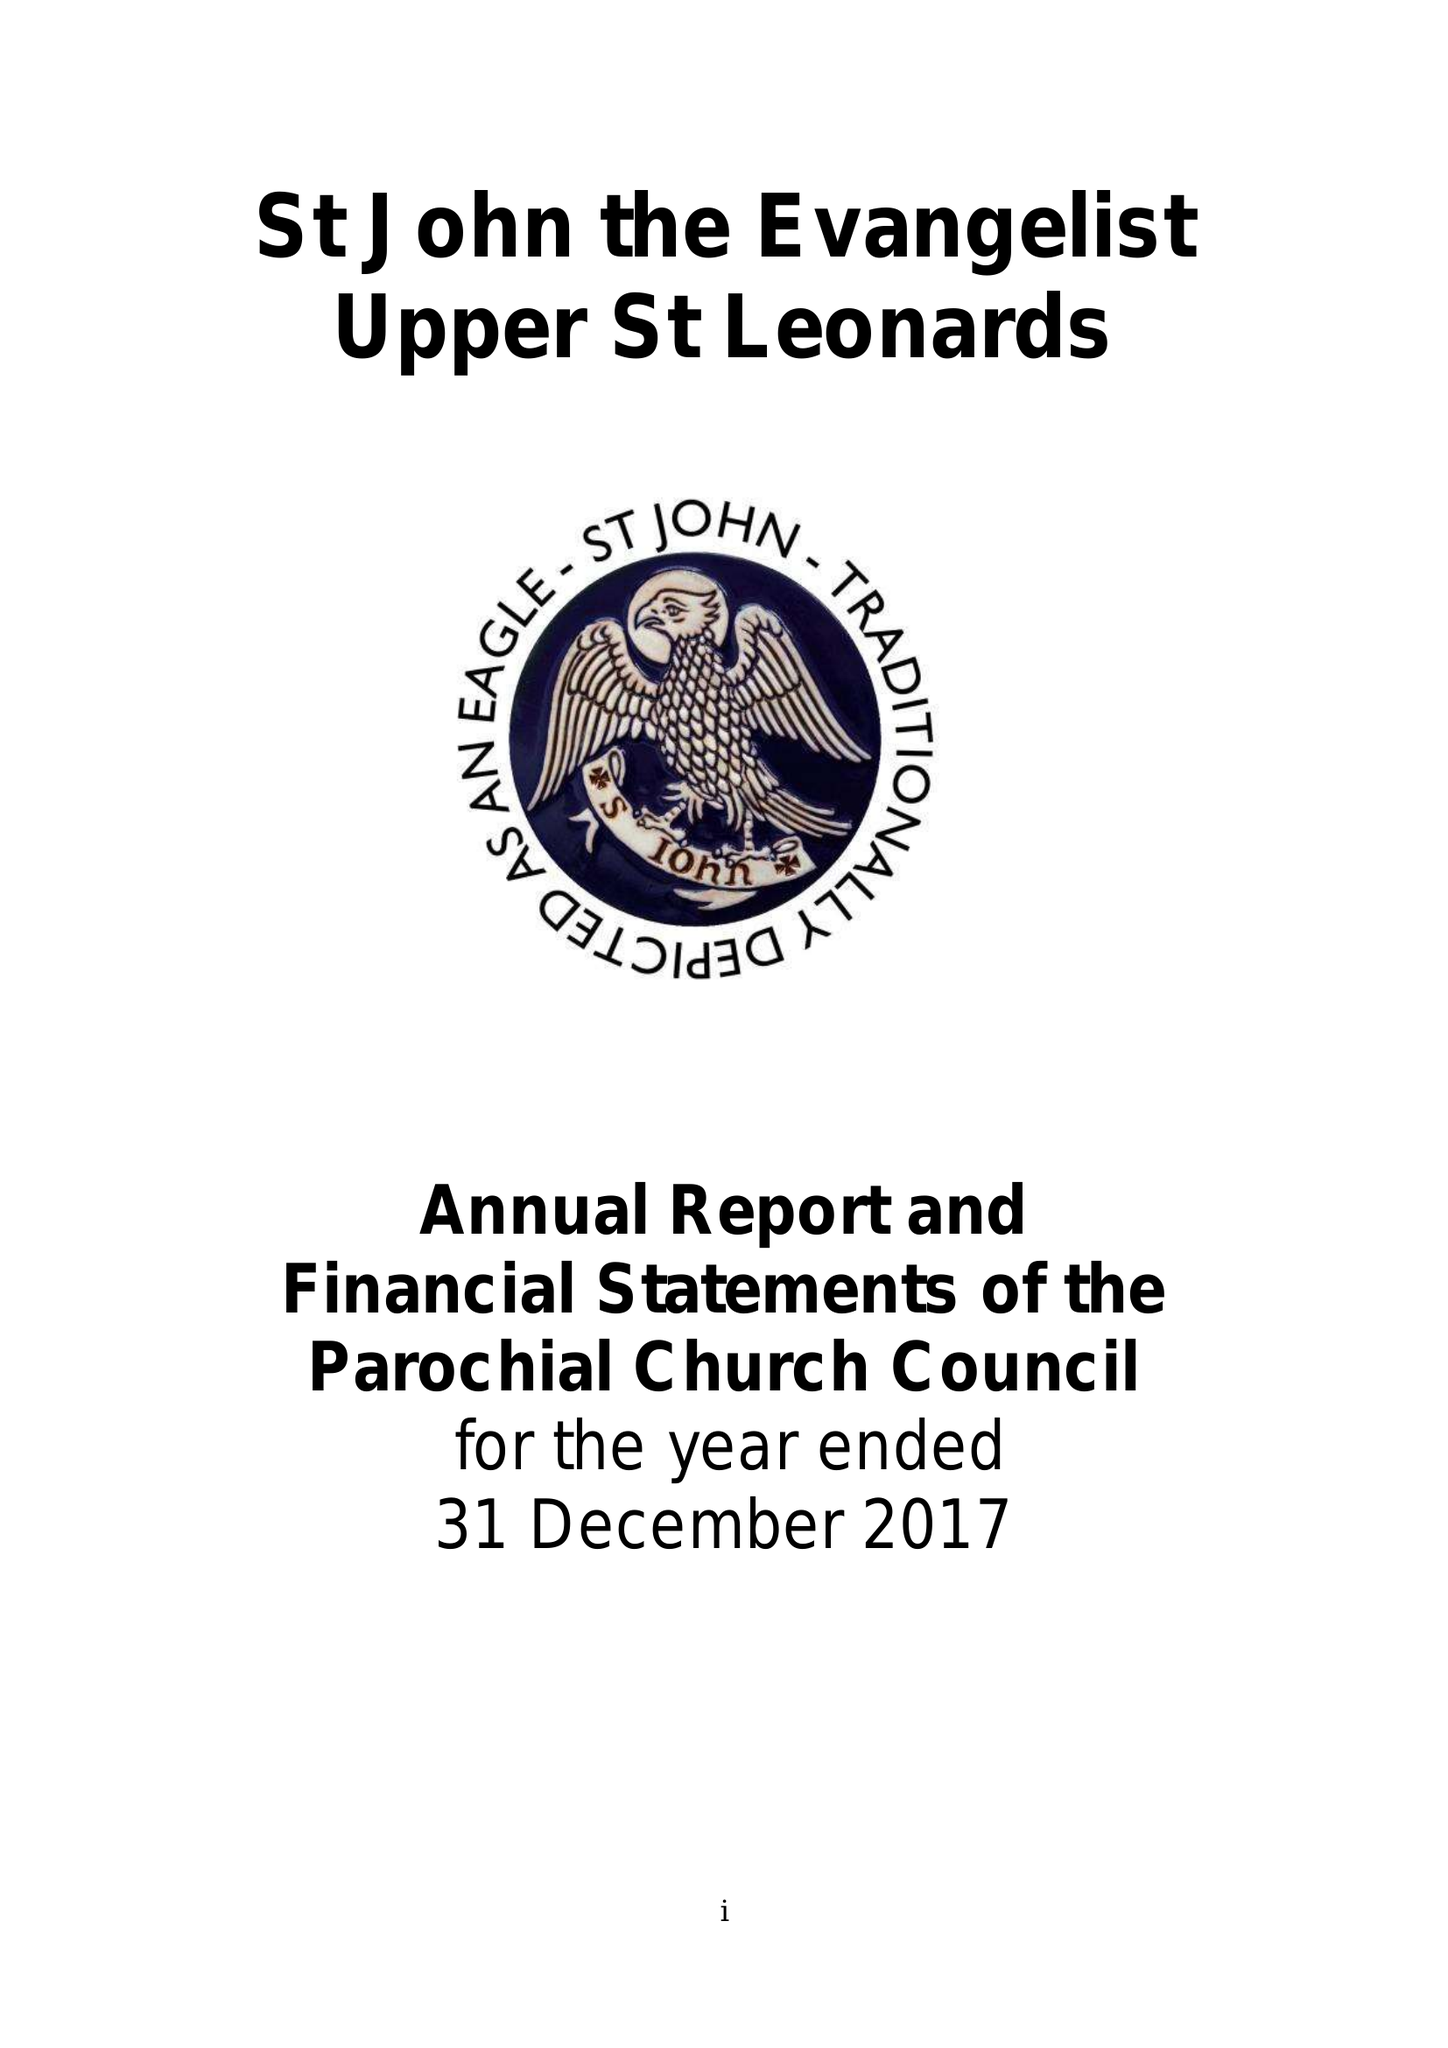What is the value for the address__post_town?
Answer the question using a single word or phrase. ST. LEONARDS-ON-SEA 